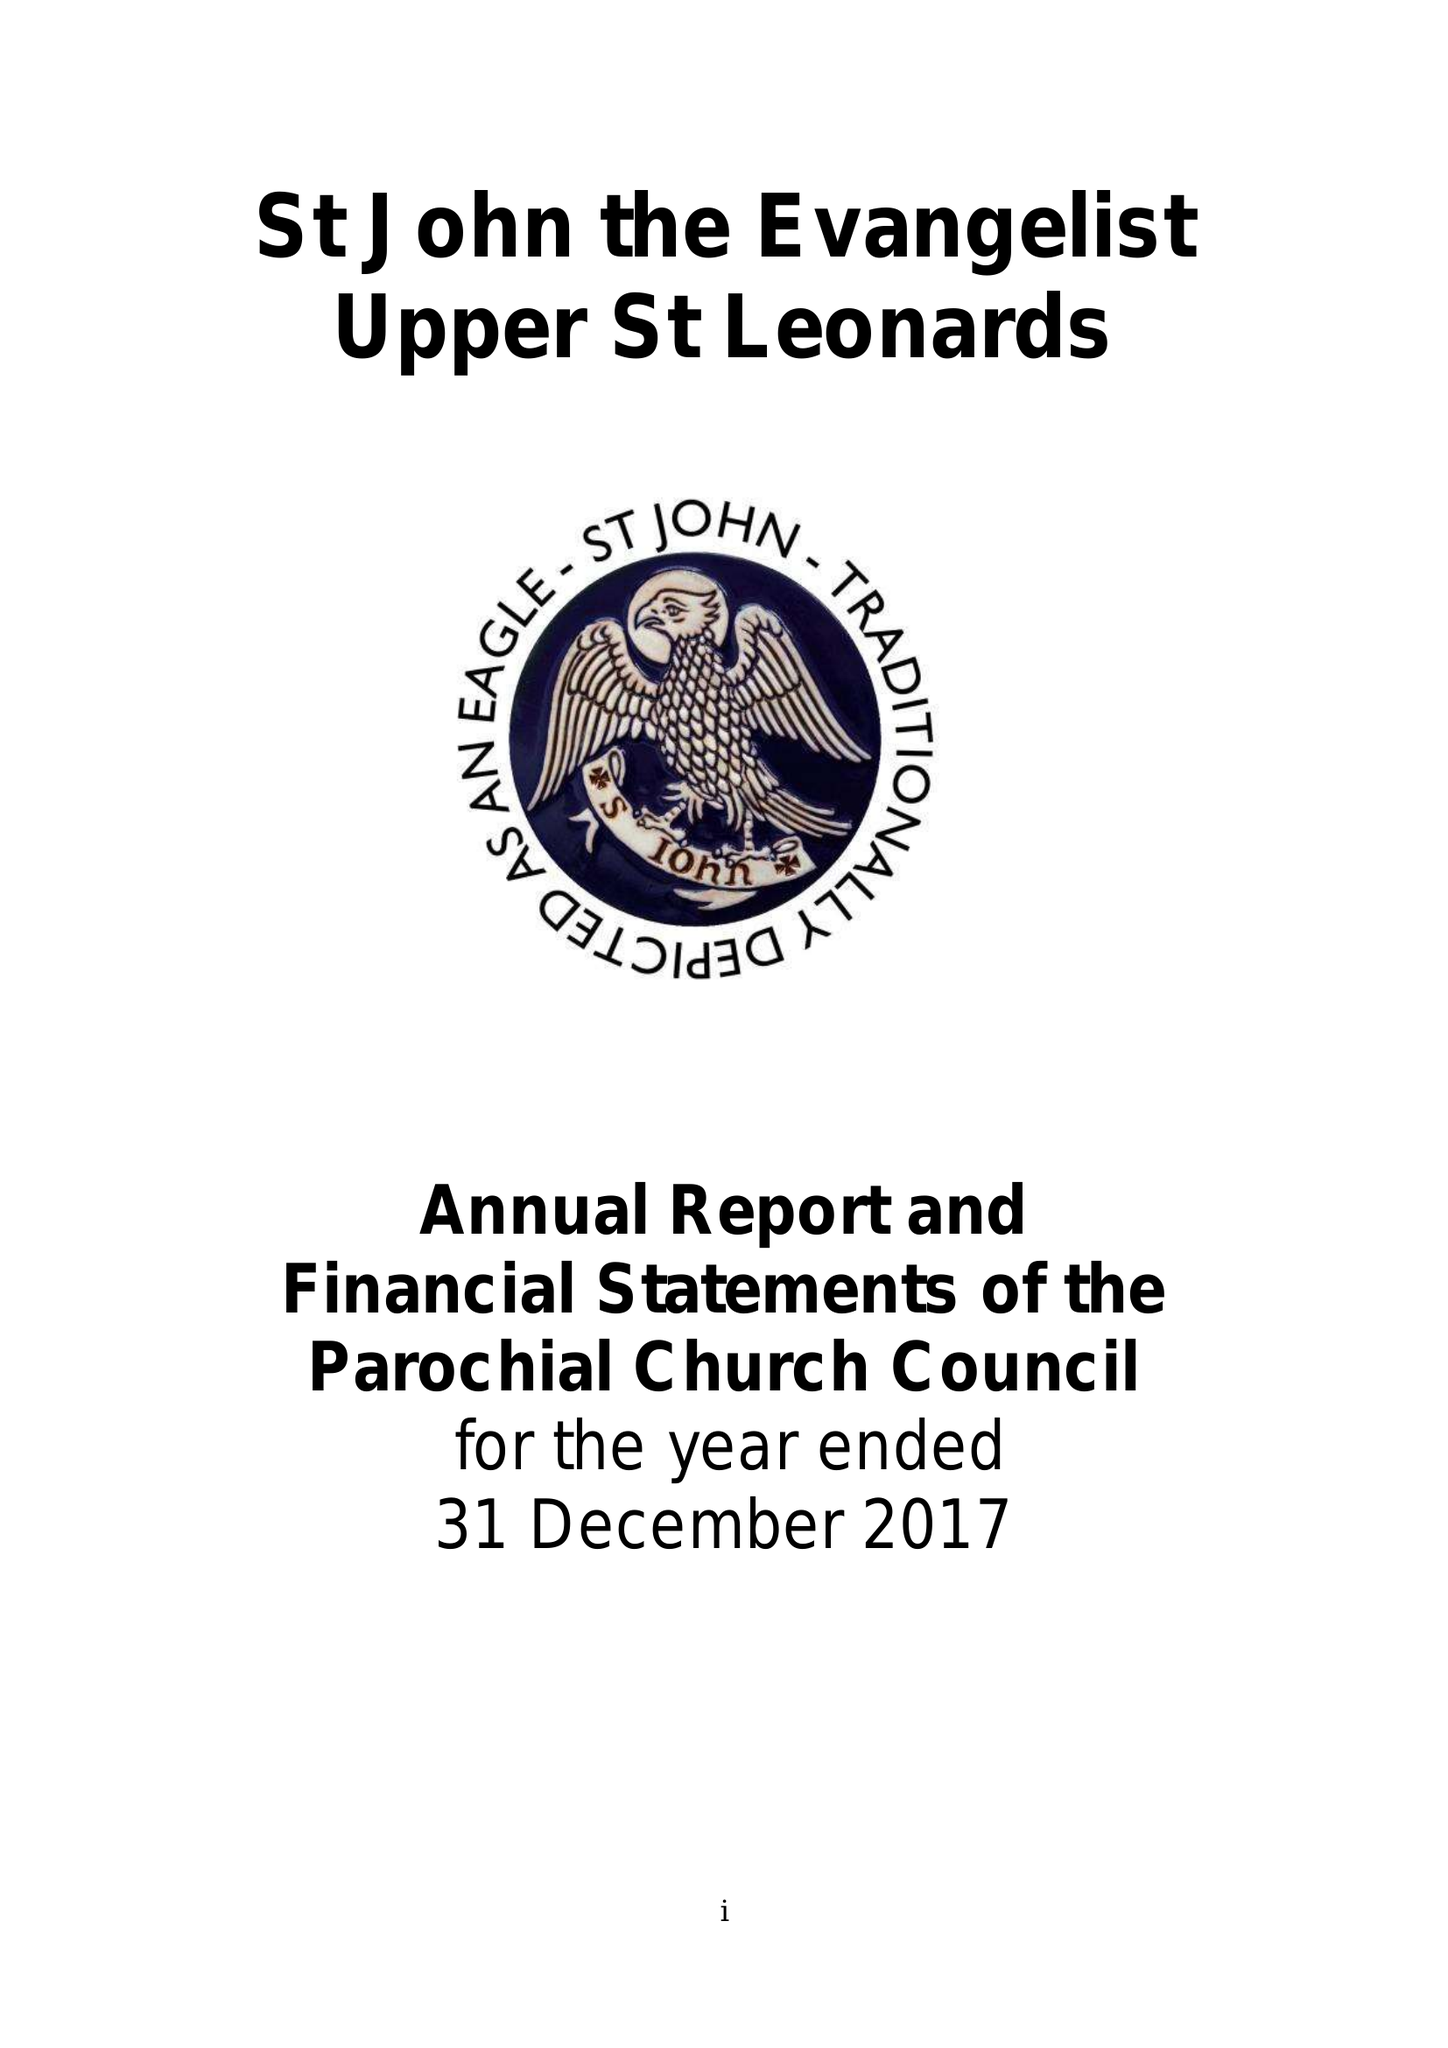What is the value for the address__post_town?
Answer the question using a single word or phrase. ST. LEONARDS-ON-SEA 